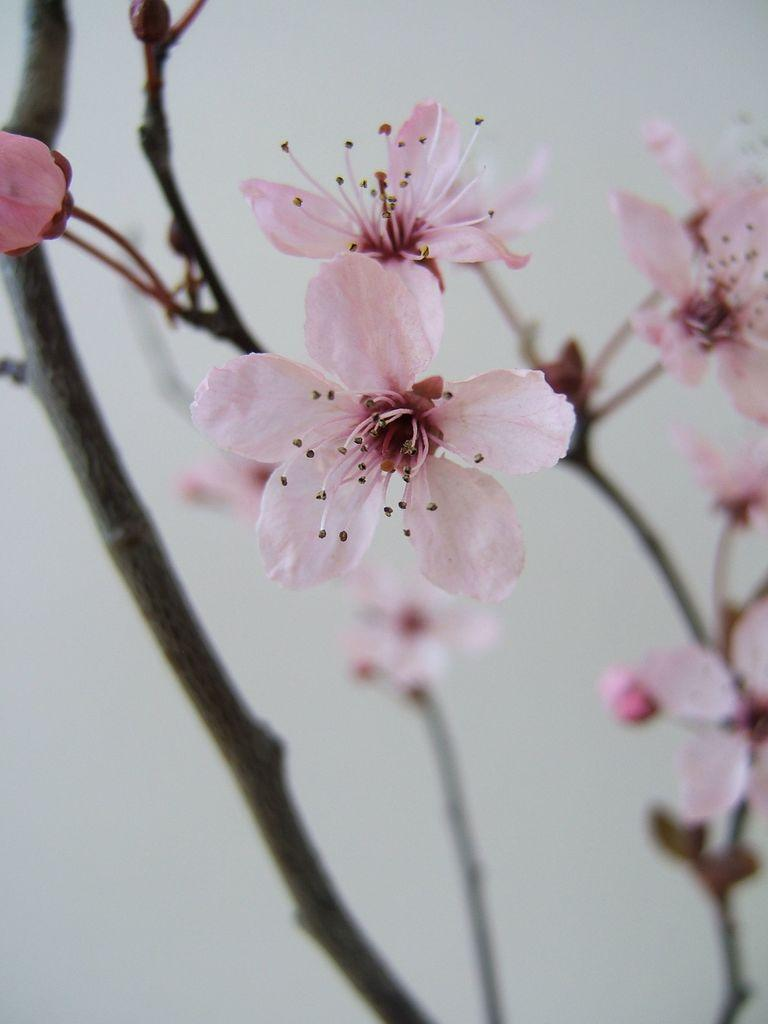What type of vegetation can be seen on the branches of the tree in the image? There are flowers on the branches of the tree in the image. What type of meat is being served for dinner in the image? There is no dinner or meat present in the image; it only features a tree with flowers on its branches. 